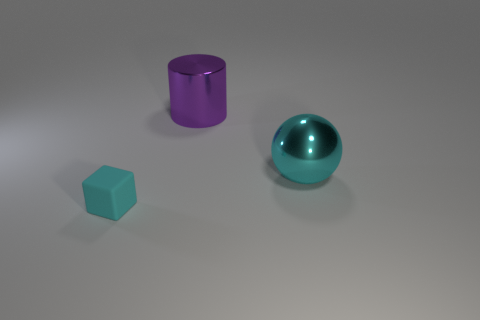Add 3 cylinders. How many objects exist? 6 Subtract all spheres. How many objects are left? 2 Add 1 small cubes. How many small cubes are left? 2 Add 3 small matte things. How many small matte things exist? 4 Subtract 0 purple spheres. How many objects are left? 3 Subtract 1 cylinders. How many cylinders are left? 0 Subtract all big cyan matte cylinders. Subtract all big metal things. How many objects are left? 1 